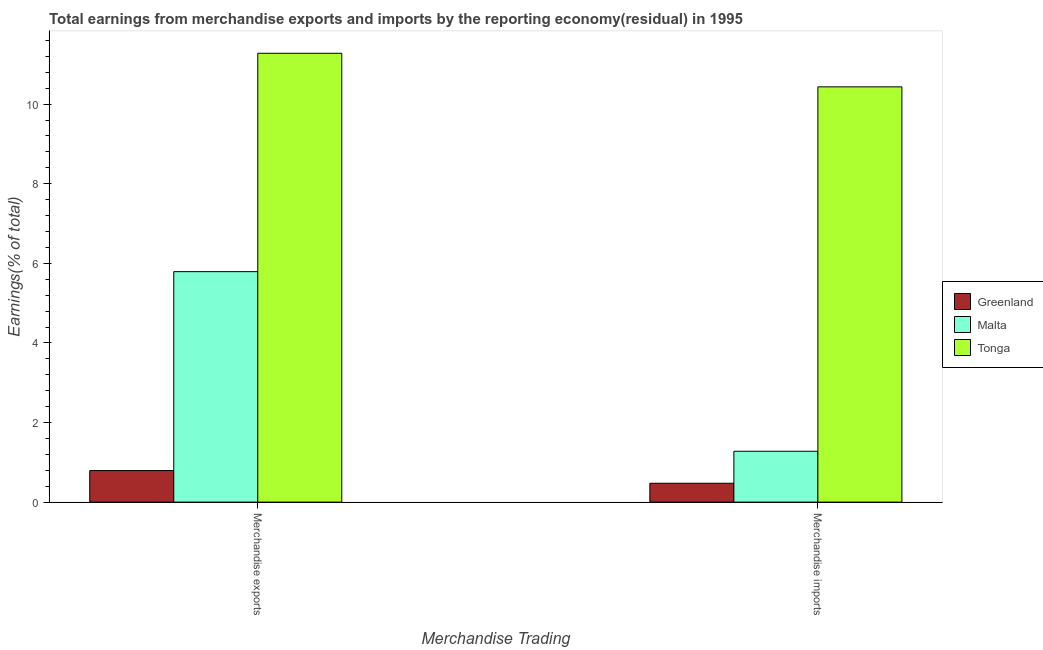How many different coloured bars are there?
Provide a short and direct response. 3. Are the number of bars on each tick of the X-axis equal?
Provide a short and direct response. Yes. How many bars are there on the 1st tick from the right?
Make the answer very short. 3. What is the label of the 1st group of bars from the left?
Offer a very short reply. Merchandise exports. What is the earnings from merchandise imports in Malta?
Ensure brevity in your answer.  1.28. Across all countries, what is the maximum earnings from merchandise imports?
Your response must be concise. 10.43. Across all countries, what is the minimum earnings from merchandise imports?
Provide a succinct answer. 0.47. In which country was the earnings from merchandise exports maximum?
Your response must be concise. Tonga. In which country was the earnings from merchandise imports minimum?
Give a very brief answer. Greenland. What is the total earnings from merchandise imports in the graph?
Provide a succinct answer. 12.19. What is the difference between the earnings from merchandise exports in Malta and that in Greenland?
Offer a terse response. 5. What is the difference between the earnings from merchandise exports in Tonga and the earnings from merchandise imports in Malta?
Offer a terse response. 10. What is the average earnings from merchandise imports per country?
Provide a short and direct response. 4.06. What is the difference between the earnings from merchandise imports and earnings from merchandise exports in Malta?
Offer a terse response. -4.51. In how many countries, is the earnings from merchandise imports greater than 6.8 %?
Provide a succinct answer. 1. What is the ratio of the earnings from merchandise imports in Greenland to that in Malta?
Offer a very short reply. 0.37. In how many countries, is the earnings from merchandise imports greater than the average earnings from merchandise imports taken over all countries?
Give a very brief answer. 1. What does the 2nd bar from the left in Merchandise imports represents?
Provide a succinct answer. Malta. What does the 2nd bar from the right in Merchandise imports represents?
Provide a succinct answer. Malta. Does the graph contain grids?
Your answer should be compact. No. How many legend labels are there?
Offer a terse response. 3. How are the legend labels stacked?
Provide a succinct answer. Vertical. What is the title of the graph?
Keep it short and to the point. Total earnings from merchandise exports and imports by the reporting economy(residual) in 1995. What is the label or title of the X-axis?
Offer a terse response. Merchandise Trading. What is the label or title of the Y-axis?
Give a very brief answer. Earnings(% of total). What is the Earnings(% of total) in Greenland in Merchandise exports?
Offer a terse response. 0.79. What is the Earnings(% of total) in Malta in Merchandise exports?
Offer a terse response. 5.79. What is the Earnings(% of total) in Tonga in Merchandise exports?
Provide a short and direct response. 11.28. What is the Earnings(% of total) of Greenland in Merchandise imports?
Offer a very short reply. 0.47. What is the Earnings(% of total) of Malta in Merchandise imports?
Provide a short and direct response. 1.28. What is the Earnings(% of total) of Tonga in Merchandise imports?
Provide a short and direct response. 10.43. Across all Merchandise Trading, what is the maximum Earnings(% of total) in Greenland?
Keep it short and to the point. 0.79. Across all Merchandise Trading, what is the maximum Earnings(% of total) of Malta?
Give a very brief answer. 5.79. Across all Merchandise Trading, what is the maximum Earnings(% of total) of Tonga?
Ensure brevity in your answer.  11.28. Across all Merchandise Trading, what is the minimum Earnings(% of total) of Greenland?
Offer a terse response. 0.47. Across all Merchandise Trading, what is the minimum Earnings(% of total) in Malta?
Ensure brevity in your answer.  1.28. Across all Merchandise Trading, what is the minimum Earnings(% of total) in Tonga?
Ensure brevity in your answer.  10.43. What is the total Earnings(% of total) of Greenland in the graph?
Provide a short and direct response. 1.27. What is the total Earnings(% of total) of Malta in the graph?
Keep it short and to the point. 7.07. What is the total Earnings(% of total) in Tonga in the graph?
Provide a short and direct response. 21.71. What is the difference between the Earnings(% of total) of Greenland in Merchandise exports and that in Merchandise imports?
Make the answer very short. 0.32. What is the difference between the Earnings(% of total) in Malta in Merchandise exports and that in Merchandise imports?
Provide a succinct answer. 4.51. What is the difference between the Earnings(% of total) in Tonga in Merchandise exports and that in Merchandise imports?
Keep it short and to the point. 0.84. What is the difference between the Earnings(% of total) in Greenland in Merchandise exports and the Earnings(% of total) in Malta in Merchandise imports?
Ensure brevity in your answer.  -0.48. What is the difference between the Earnings(% of total) of Greenland in Merchandise exports and the Earnings(% of total) of Tonga in Merchandise imports?
Ensure brevity in your answer.  -9.64. What is the difference between the Earnings(% of total) in Malta in Merchandise exports and the Earnings(% of total) in Tonga in Merchandise imports?
Provide a succinct answer. -4.64. What is the average Earnings(% of total) of Greenland per Merchandise Trading?
Offer a very short reply. 0.63. What is the average Earnings(% of total) of Malta per Merchandise Trading?
Offer a very short reply. 3.53. What is the average Earnings(% of total) in Tonga per Merchandise Trading?
Provide a succinct answer. 10.86. What is the difference between the Earnings(% of total) in Greenland and Earnings(% of total) in Malta in Merchandise exports?
Provide a succinct answer. -5. What is the difference between the Earnings(% of total) of Greenland and Earnings(% of total) of Tonga in Merchandise exports?
Ensure brevity in your answer.  -10.49. What is the difference between the Earnings(% of total) of Malta and Earnings(% of total) of Tonga in Merchandise exports?
Make the answer very short. -5.49. What is the difference between the Earnings(% of total) of Greenland and Earnings(% of total) of Malta in Merchandise imports?
Your answer should be very brief. -0.8. What is the difference between the Earnings(% of total) of Greenland and Earnings(% of total) of Tonga in Merchandise imports?
Give a very brief answer. -9.96. What is the difference between the Earnings(% of total) of Malta and Earnings(% of total) of Tonga in Merchandise imports?
Your response must be concise. -9.16. What is the ratio of the Earnings(% of total) in Greenland in Merchandise exports to that in Merchandise imports?
Keep it short and to the point. 1.67. What is the ratio of the Earnings(% of total) in Malta in Merchandise exports to that in Merchandise imports?
Your answer should be very brief. 4.53. What is the ratio of the Earnings(% of total) in Tonga in Merchandise exports to that in Merchandise imports?
Your answer should be compact. 1.08. What is the difference between the highest and the second highest Earnings(% of total) of Greenland?
Offer a very short reply. 0.32. What is the difference between the highest and the second highest Earnings(% of total) of Malta?
Your answer should be very brief. 4.51. What is the difference between the highest and the second highest Earnings(% of total) in Tonga?
Offer a terse response. 0.84. What is the difference between the highest and the lowest Earnings(% of total) in Greenland?
Offer a very short reply. 0.32. What is the difference between the highest and the lowest Earnings(% of total) in Malta?
Provide a succinct answer. 4.51. What is the difference between the highest and the lowest Earnings(% of total) of Tonga?
Make the answer very short. 0.84. 